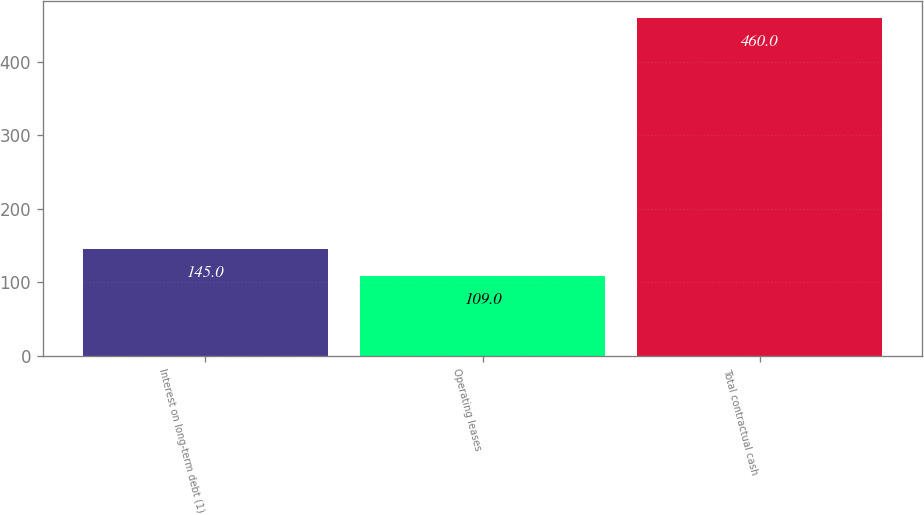<chart> <loc_0><loc_0><loc_500><loc_500><bar_chart><fcel>Interest on long-term debt (1)<fcel>Operating leases<fcel>Total contractual cash<nl><fcel>145<fcel>109<fcel>460<nl></chart> 